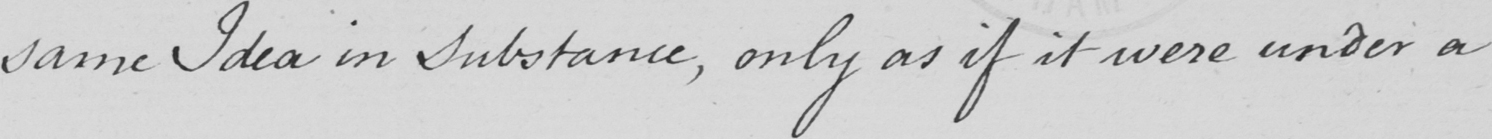Please transcribe the handwritten text in this image. same Idea in Substance , only as if it were under a 